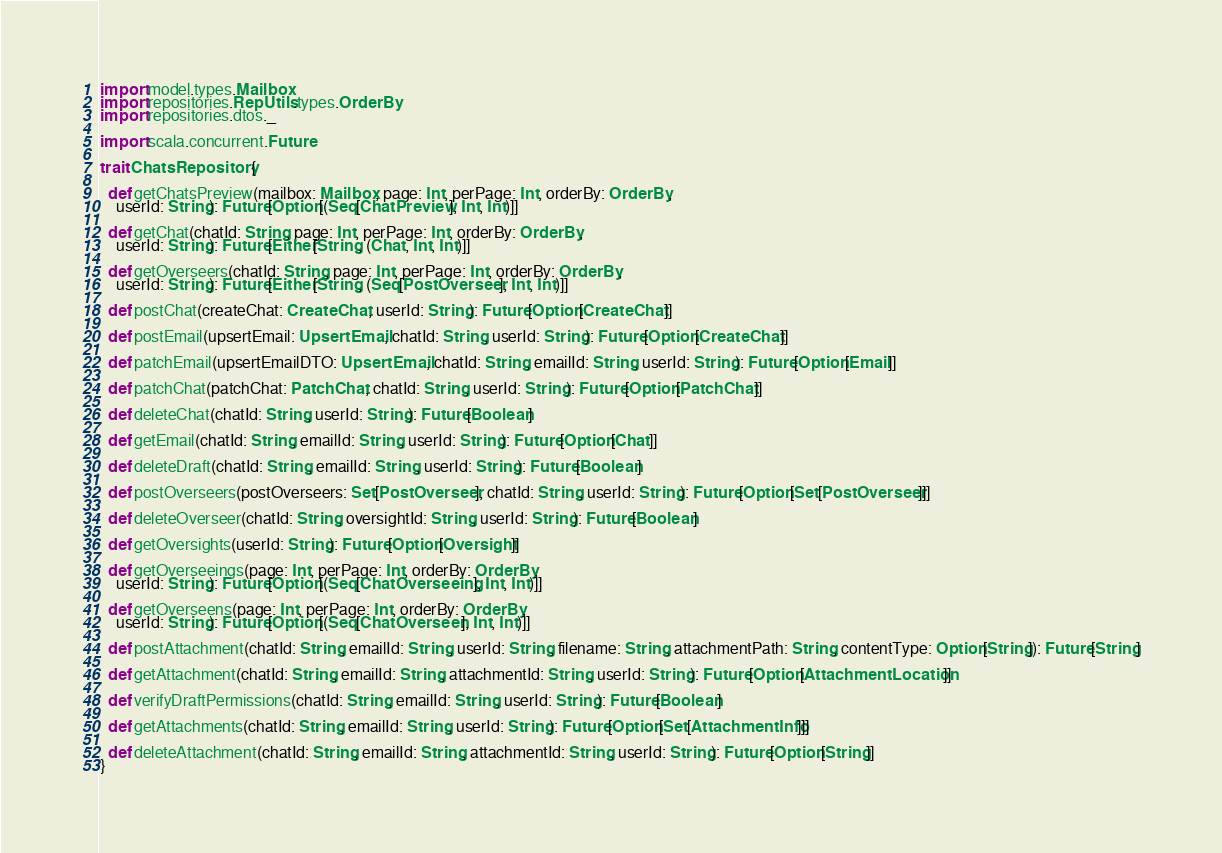<code> <loc_0><loc_0><loc_500><loc_500><_Scala_>import model.types.Mailbox
import repositories.RepUtils.types.OrderBy
import repositories.dtos._

import scala.concurrent.Future

trait ChatsRepository {

  def getChatsPreview(mailbox: Mailbox, page: Int, perPage: Int, orderBy: OrderBy,
    userId: String): Future[Option[(Seq[ChatPreview], Int, Int)]]

  def getChat(chatId: String, page: Int, perPage: Int, orderBy: OrderBy,
    userId: String): Future[Either[String, (Chat, Int, Int)]]

  def getOverseers(chatId: String, page: Int, perPage: Int, orderBy: OrderBy,
    userId: String): Future[Either[String, (Seq[PostOverseer], Int, Int)]]

  def postChat(createChat: CreateChat, userId: String): Future[Option[CreateChat]]

  def postEmail(upsertEmail: UpsertEmail, chatId: String, userId: String): Future[Option[CreateChat]]

  def patchEmail(upsertEmailDTO: UpsertEmail, chatId: String, emailId: String, userId: String): Future[Option[Email]]

  def patchChat(patchChat: PatchChat, chatId: String, userId: String): Future[Option[PatchChat]]

  def deleteChat(chatId: String, userId: String): Future[Boolean]

  def getEmail(chatId: String, emailId: String, userId: String): Future[Option[Chat]]

  def deleteDraft(chatId: String, emailId: String, userId: String): Future[Boolean]

  def postOverseers(postOverseers: Set[PostOverseer], chatId: String, userId: String): Future[Option[Set[PostOverseer]]]

  def deleteOverseer(chatId: String, oversightId: String, userId: String): Future[Boolean]

  def getOversights(userId: String): Future[Option[Oversight]]

  def getOverseeings(page: Int, perPage: Int, orderBy: OrderBy,
    userId: String): Future[Option[(Seq[ChatOverseeing], Int, Int)]]

  def getOverseens(page: Int, perPage: Int, orderBy: OrderBy,
    userId: String): Future[Option[(Seq[ChatOverseen], Int, Int)]]

  def postAttachment(chatId: String, emailId: String, userId: String, filename: String, attachmentPath: String, contentType: Option[String]): Future[String]

  def getAttachment(chatId: String, emailId: String, attachmentId: String, userId: String): Future[Option[AttachmentLocation]]

  def verifyDraftPermissions(chatId: String, emailId: String, userId: String): Future[Boolean]

  def getAttachments(chatId: String, emailId: String, userId: String): Future[Option[Set[AttachmentInfo]]]

  def deleteAttachment(chatId: String, emailId: String, attachmentId: String, userId: String): Future[Option[String]]
}
</code> 